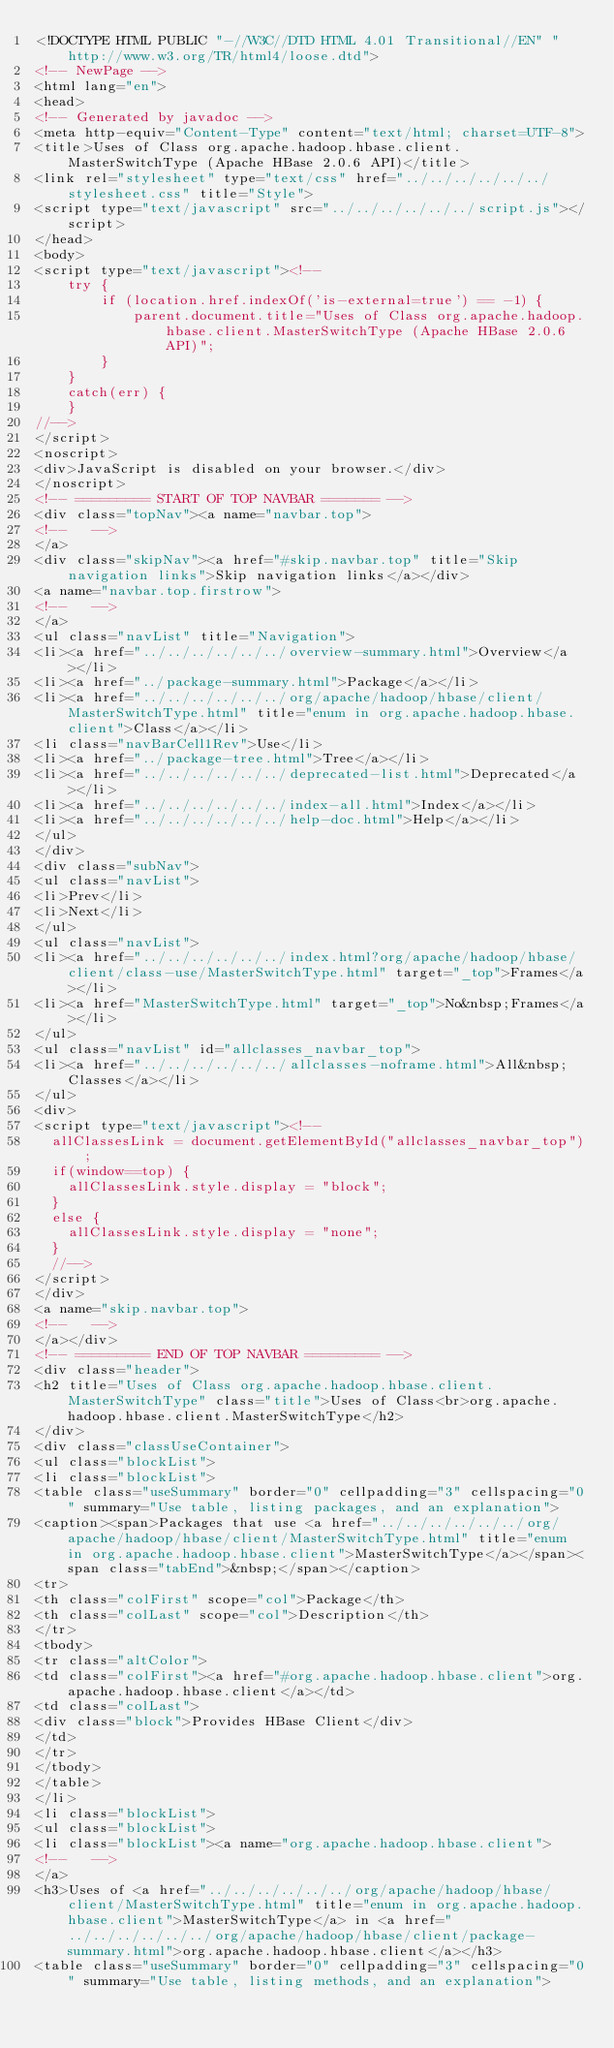<code> <loc_0><loc_0><loc_500><loc_500><_HTML_><!DOCTYPE HTML PUBLIC "-//W3C//DTD HTML 4.01 Transitional//EN" "http://www.w3.org/TR/html4/loose.dtd">
<!-- NewPage -->
<html lang="en">
<head>
<!-- Generated by javadoc -->
<meta http-equiv="Content-Type" content="text/html; charset=UTF-8">
<title>Uses of Class org.apache.hadoop.hbase.client.MasterSwitchType (Apache HBase 2.0.6 API)</title>
<link rel="stylesheet" type="text/css" href="../../../../../../stylesheet.css" title="Style">
<script type="text/javascript" src="../../../../../../script.js"></script>
</head>
<body>
<script type="text/javascript"><!--
    try {
        if (location.href.indexOf('is-external=true') == -1) {
            parent.document.title="Uses of Class org.apache.hadoop.hbase.client.MasterSwitchType (Apache HBase 2.0.6 API)";
        }
    }
    catch(err) {
    }
//-->
</script>
<noscript>
<div>JavaScript is disabled on your browser.</div>
</noscript>
<!-- ========= START OF TOP NAVBAR ======= -->
<div class="topNav"><a name="navbar.top">
<!--   -->
</a>
<div class="skipNav"><a href="#skip.navbar.top" title="Skip navigation links">Skip navigation links</a></div>
<a name="navbar.top.firstrow">
<!--   -->
</a>
<ul class="navList" title="Navigation">
<li><a href="../../../../../../overview-summary.html">Overview</a></li>
<li><a href="../package-summary.html">Package</a></li>
<li><a href="../../../../../../org/apache/hadoop/hbase/client/MasterSwitchType.html" title="enum in org.apache.hadoop.hbase.client">Class</a></li>
<li class="navBarCell1Rev">Use</li>
<li><a href="../package-tree.html">Tree</a></li>
<li><a href="../../../../../../deprecated-list.html">Deprecated</a></li>
<li><a href="../../../../../../index-all.html">Index</a></li>
<li><a href="../../../../../../help-doc.html">Help</a></li>
</ul>
</div>
<div class="subNav">
<ul class="navList">
<li>Prev</li>
<li>Next</li>
</ul>
<ul class="navList">
<li><a href="../../../../../../index.html?org/apache/hadoop/hbase/client/class-use/MasterSwitchType.html" target="_top">Frames</a></li>
<li><a href="MasterSwitchType.html" target="_top">No&nbsp;Frames</a></li>
</ul>
<ul class="navList" id="allclasses_navbar_top">
<li><a href="../../../../../../allclasses-noframe.html">All&nbsp;Classes</a></li>
</ul>
<div>
<script type="text/javascript"><!--
  allClassesLink = document.getElementById("allclasses_navbar_top");
  if(window==top) {
    allClassesLink.style.display = "block";
  }
  else {
    allClassesLink.style.display = "none";
  }
  //-->
</script>
</div>
<a name="skip.navbar.top">
<!--   -->
</a></div>
<!-- ========= END OF TOP NAVBAR ========= -->
<div class="header">
<h2 title="Uses of Class org.apache.hadoop.hbase.client.MasterSwitchType" class="title">Uses of Class<br>org.apache.hadoop.hbase.client.MasterSwitchType</h2>
</div>
<div class="classUseContainer">
<ul class="blockList">
<li class="blockList">
<table class="useSummary" border="0" cellpadding="3" cellspacing="0" summary="Use table, listing packages, and an explanation">
<caption><span>Packages that use <a href="../../../../../../org/apache/hadoop/hbase/client/MasterSwitchType.html" title="enum in org.apache.hadoop.hbase.client">MasterSwitchType</a></span><span class="tabEnd">&nbsp;</span></caption>
<tr>
<th class="colFirst" scope="col">Package</th>
<th class="colLast" scope="col">Description</th>
</tr>
<tbody>
<tr class="altColor">
<td class="colFirst"><a href="#org.apache.hadoop.hbase.client">org.apache.hadoop.hbase.client</a></td>
<td class="colLast">
<div class="block">Provides HBase Client</div>
</td>
</tr>
</tbody>
</table>
</li>
<li class="blockList">
<ul class="blockList">
<li class="blockList"><a name="org.apache.hadoop.hbase.client">
<!--   -->
</a>
<h3>Uses of <a href="../../../../../../org/apache/hadoop/hbase/client/MasterSwitchType.html" title="enum in org.apache.hadoop.hbase.client">MasterSwitchType</a> in <a href="../../../../../../org/apache/hadoop/hbase/client/package-summary.html">org.apache.hadoop.hbase.client</a></h3>
<table class="useSummary" border="0" cellpadding="3" cellspacing="0" summary="Use table, listing methods, and an explanation"></code> 